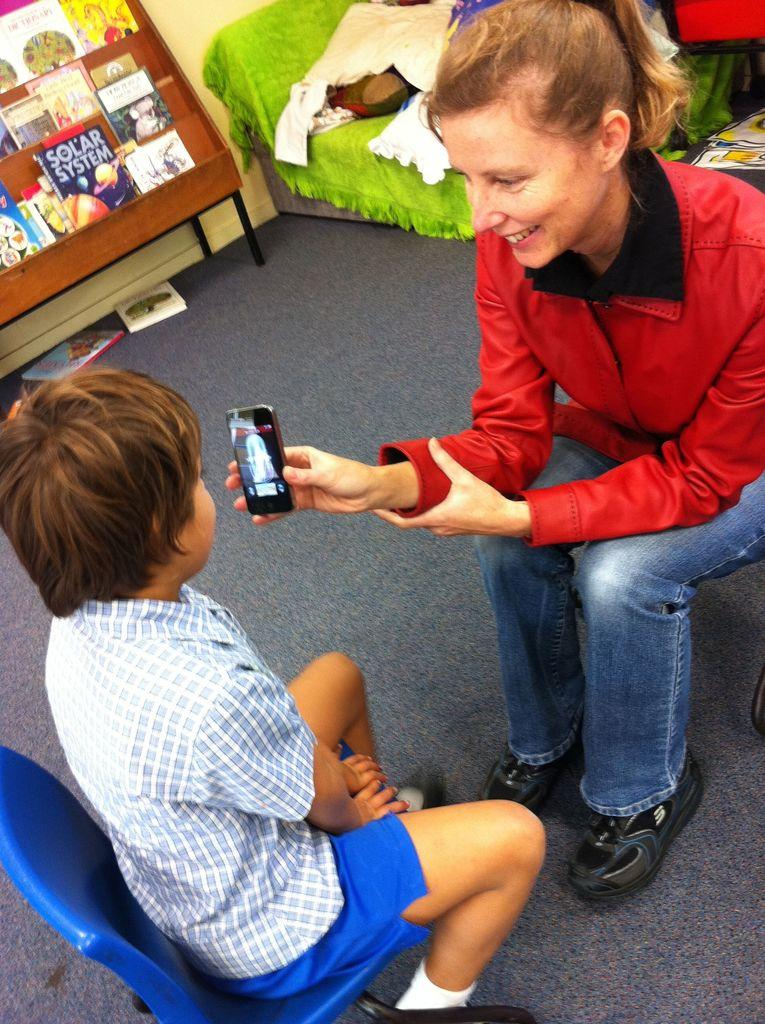<image>
Describe the image concisely. A kid is looking at a phone that a women is hold and there are a bunch of kids book in the back one is " SOLAR SYSTEM". 